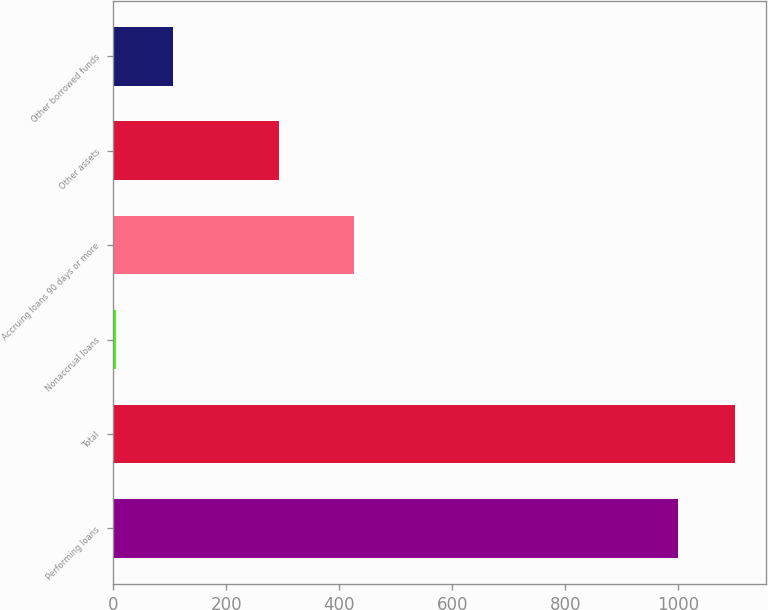Convert chart to OTSL. <chart><loc_0><loc_0><loc_500><loc_500><bar_chart><fcel>Performing loans<fcel>Total<fcel>Nonaccrual loans<fcel>Accruing loans 90 days or more<fcel>Other assets<fcel>Other borrowed funds<nl><fcel>1000<fcel>1100.5<fcel>5<fcel>427<fcel>293<fcel>105.5<nl></chart> 